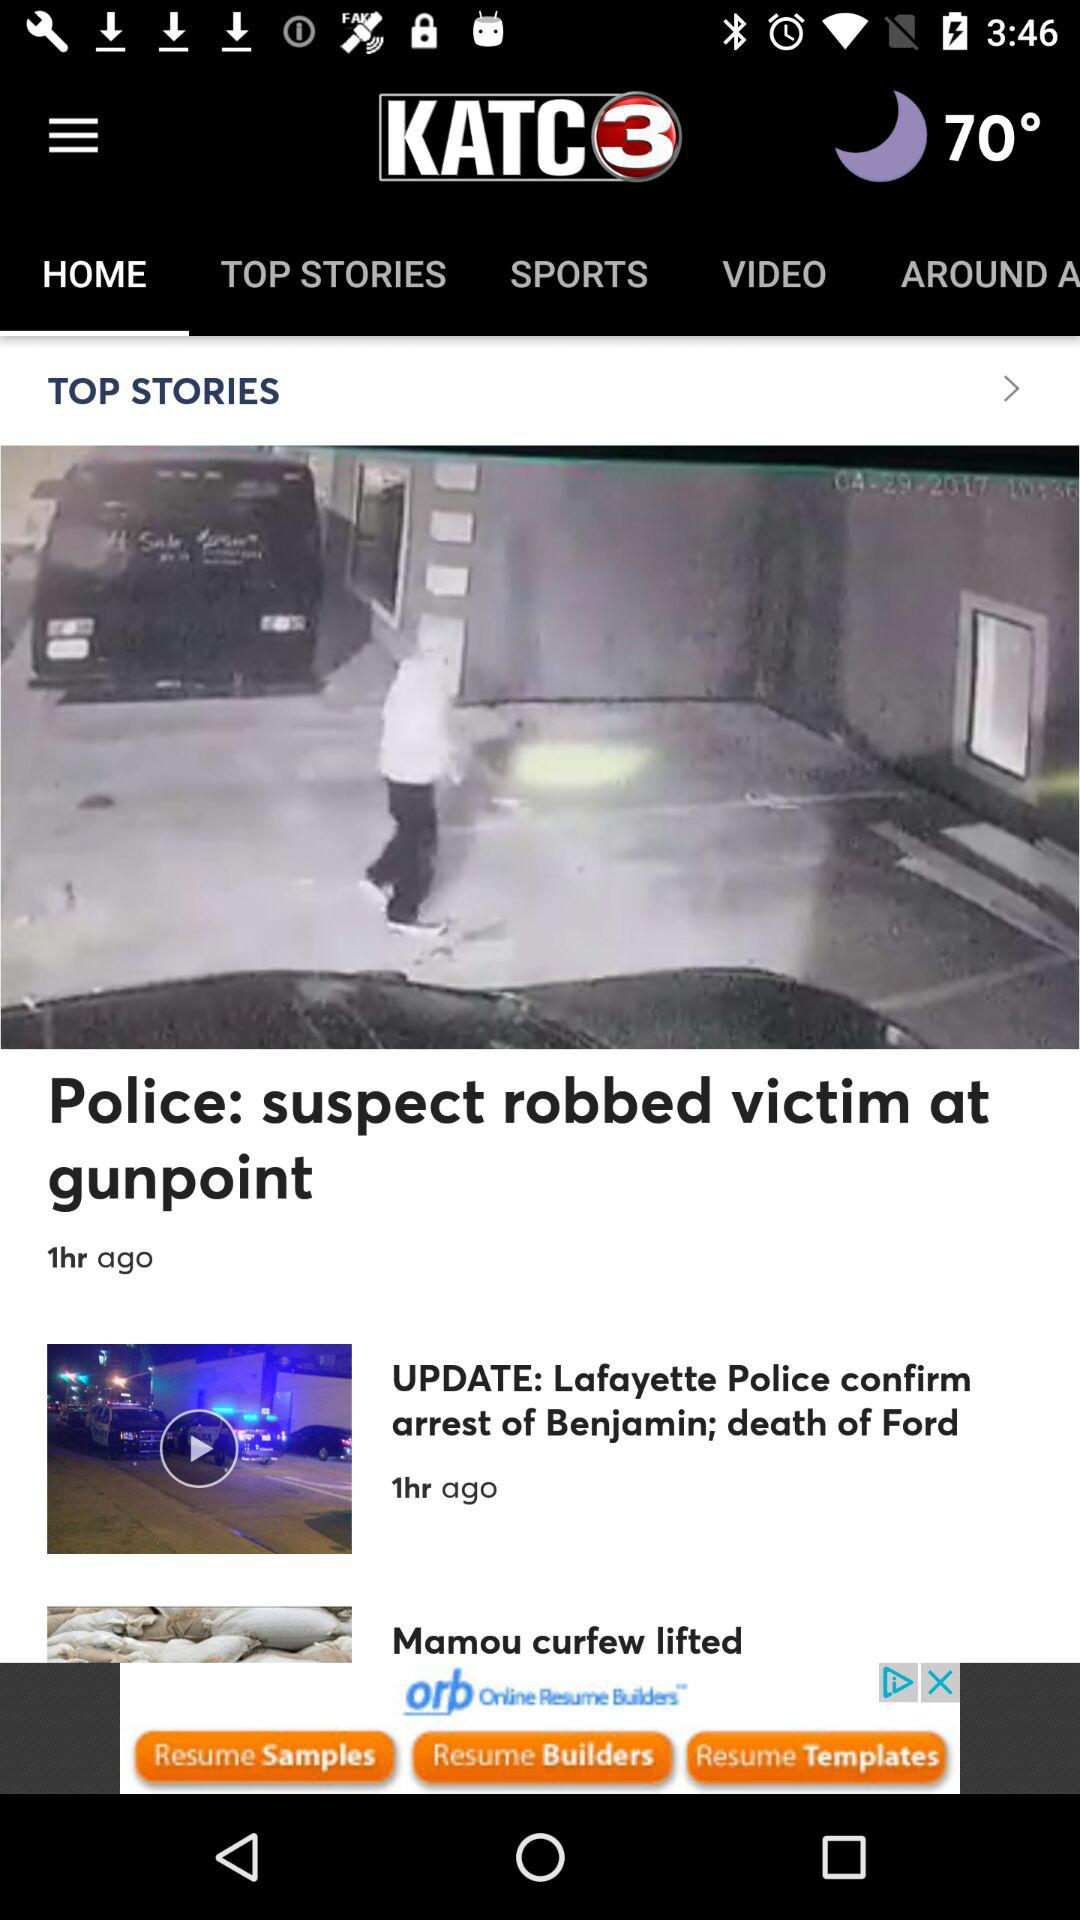Which tab am I on? You are on the "HOME" tab. 